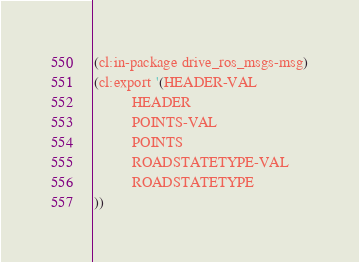<code> <loc_0><loc_0><loc_500><loc_500><_Lisp_>(cl:in-package drive_ros_msgs-msg)
(cl:export '(HEADER-VAL
          HEADER
          POINTS-VAL
          POINTS
          ROADSTATETYPE-VAL
          ROADSTATETYPE
))</code> 